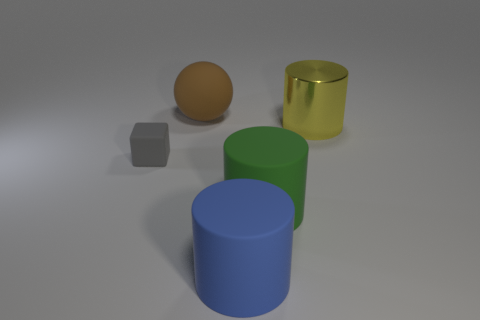Subtract all matte cylinders. How many cylinders are left? 1 Add 4 tiny metallic spheres. How many objects exist? 9 Subtract 1 spheres. How many spheres are left? 0 Add 3 tiny rubber objects. How many tiny rubber objects are left? 4 Add 3 metallic cylinders. How many metallic cylinders exist? 4 Subtract all yellow cylinders. How many cylinders are left? 2 Subtract 0 red cubes. How many objects are left? 5 Subtract all balls. How many objects are left? 4 Subtract all red cylinders. Subtract all yellow blocks. How many cylinders are left? 3 Subtract all purple spheres. How many red blocks are left? 0 